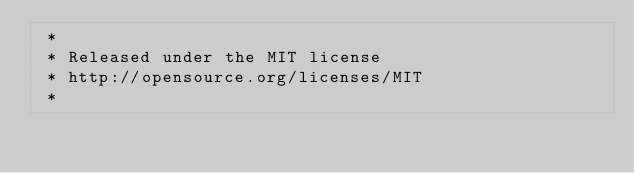<code> <loc_0><loc_0><loc_500><loc_500><_CSS_> *
 * Released under the MIT license
 * http://opensource.org/licenses/MIT
 *</code> 